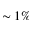<formula> <loc_0><loc_0><loc_500><loc_500>\sim 1 \%</formula> 